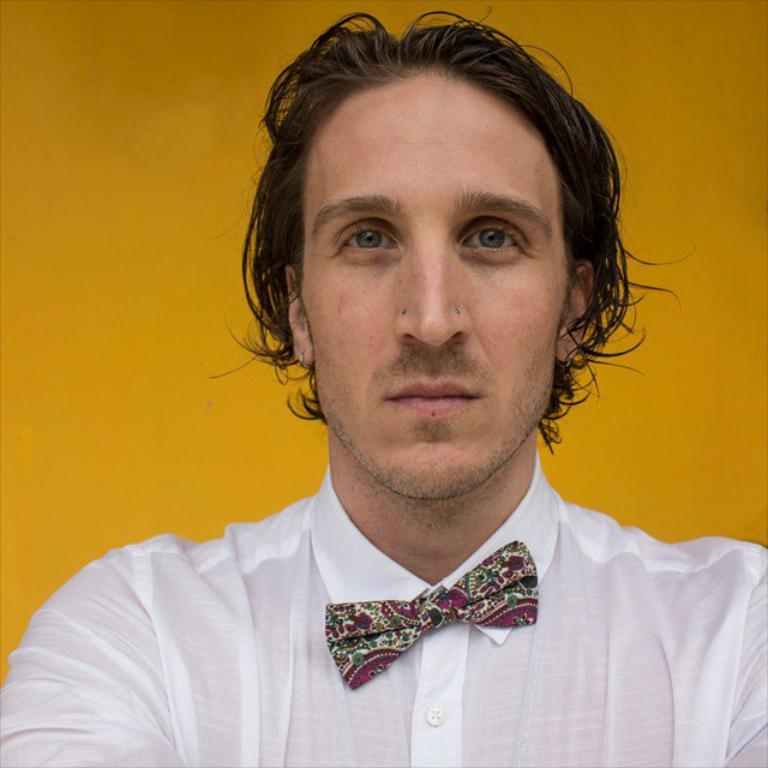Who or what is the main subject of the image? There is a person in the image. What is the person wearing in the image? The person is wearing a white shirt. What color is the background of the image? The background of the image is yellow. What type of paste is being applied to the person's wrist in the image? There is no paste or any activity involving the person's wrist in the image. 